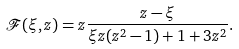<formula> <loc_0><loc_0><loc_500><loc_500>\mathcal { F } ( \xi , z ) = z \frac { z - \xi } { \xi z ( z ^ { 2 } - 1 ) + 1 + 3 z ^ { 2 } } .</formula> 